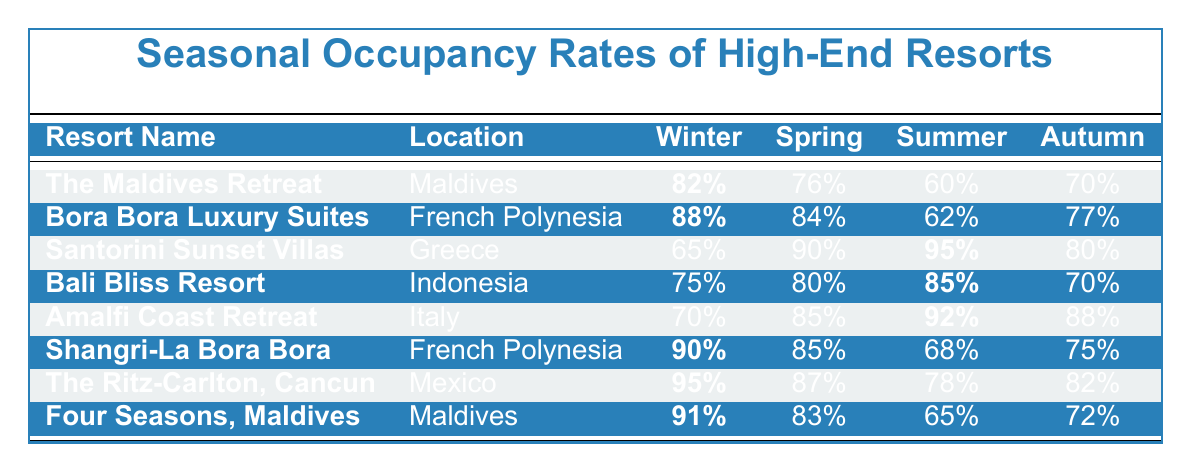What is the winter occupancy rate for The Ritz-Carlton, Cancun? The table shows that the winter occupancy rate for The Ritz-Carlton, Cancun is 95%.
Answer: 95% Which resort has the highest spring occupancy rate? From the table, Santorini Sunset Villas has the highest spring occupancy rate at 90%.
Answer: 90% What is the difference in summer occupancy rates between Bora Bora Luxury Suites and Bali Bliss Resort? Bora Bora Luxury Suites has a summer occupancy rate of 62%, while Bali Bliss Resort has 85%. The difference is 85 - 62 = 23.
Answer: 23% Is the autumn occupancy rate of Shangri-La Bora Bora higher than that of Bali Bliss Resort? Shangri-La Bora Bora has an autumn occupancy rate of 75%, while Bali Bliss Resort has 70%. Since 75 is greater than 70, the statement is true.
Answer: Yes What is the average occupancy rate for winter among all resorts listed? The winter rates are 82, 88, 65, 75, 70, 90, 95, and 91. Summing these gives 82 + 88 + 65 + 75 + 70 + 90 + 95 + 91 = 756. Dividing by 8 resorts, the average is 756 / 8 = 94.5.
Answer: 94.5 How many resorts have a summer occupancy rate greater than 80%? The resorts with summer rates above 80% are Santorini Sunset Villas (95%), Bali Bliss Resort (85%), and Amalfi Coast Retreat (92%). That gives a total of 3 resorts.
Answer: 3 Which season has the lowest occupancy rate for The Maldives Retreat? The table indicates that The Maldives Retreat has the lowest occupancy rate in summer at 60%.
Answer: 60% What is the median autumn occupancy rate for the listed resorts? The autumn rates are 70, 77, 80, 70, 88, 75, 82, and 72. Arranging these in order gives 70, 70, 75, 77, 80, 82, 88. There are 8 values; the median would be the average of the 4th and 5th numbers, (77 + 80) / 2 = 78.5.
Answer: 78.5 Which resort located in the Maldives has the highest occupancy rate during spring? The table shows that Four Seasons, Maldives has a spring occupancy rate of 83%, while The Maldives Retreat has 76%. Hence, Four Seasons has the highest rate in that season among Maldivian resorts.
Answer: 83% Which resort in French Polynesia has the lowest summer occupancy rate? The table indicates that Bora Bora Luxury Suites has a summer occupancy rate of 62%, which is lower than Shangri-La Bora Bora's 68%.
Answer: 62% 